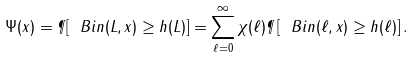<formula> <loc_0><loc_0><loc_500><loc_500>\Psi ( x ) = \P [ \ B i n ( L , x ) \geq h ( L ) ] = \sum _ { \ell = 0 } ^ { \infty } \chi ( \ell ) \P \left [ \ B i n ( \ell , x ) \geq h ( \ell ) \right ] .</formula> 